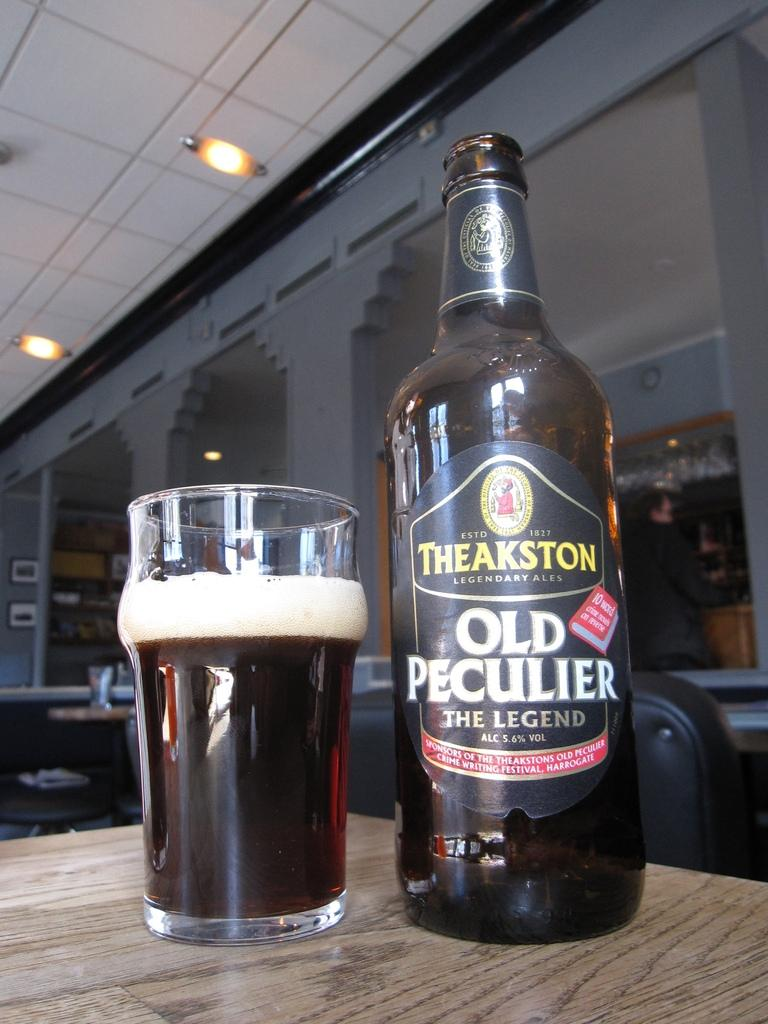<image>
Offer a succinct explanation of the picture presented. A poured beverage that is branded "Old Peculier". 